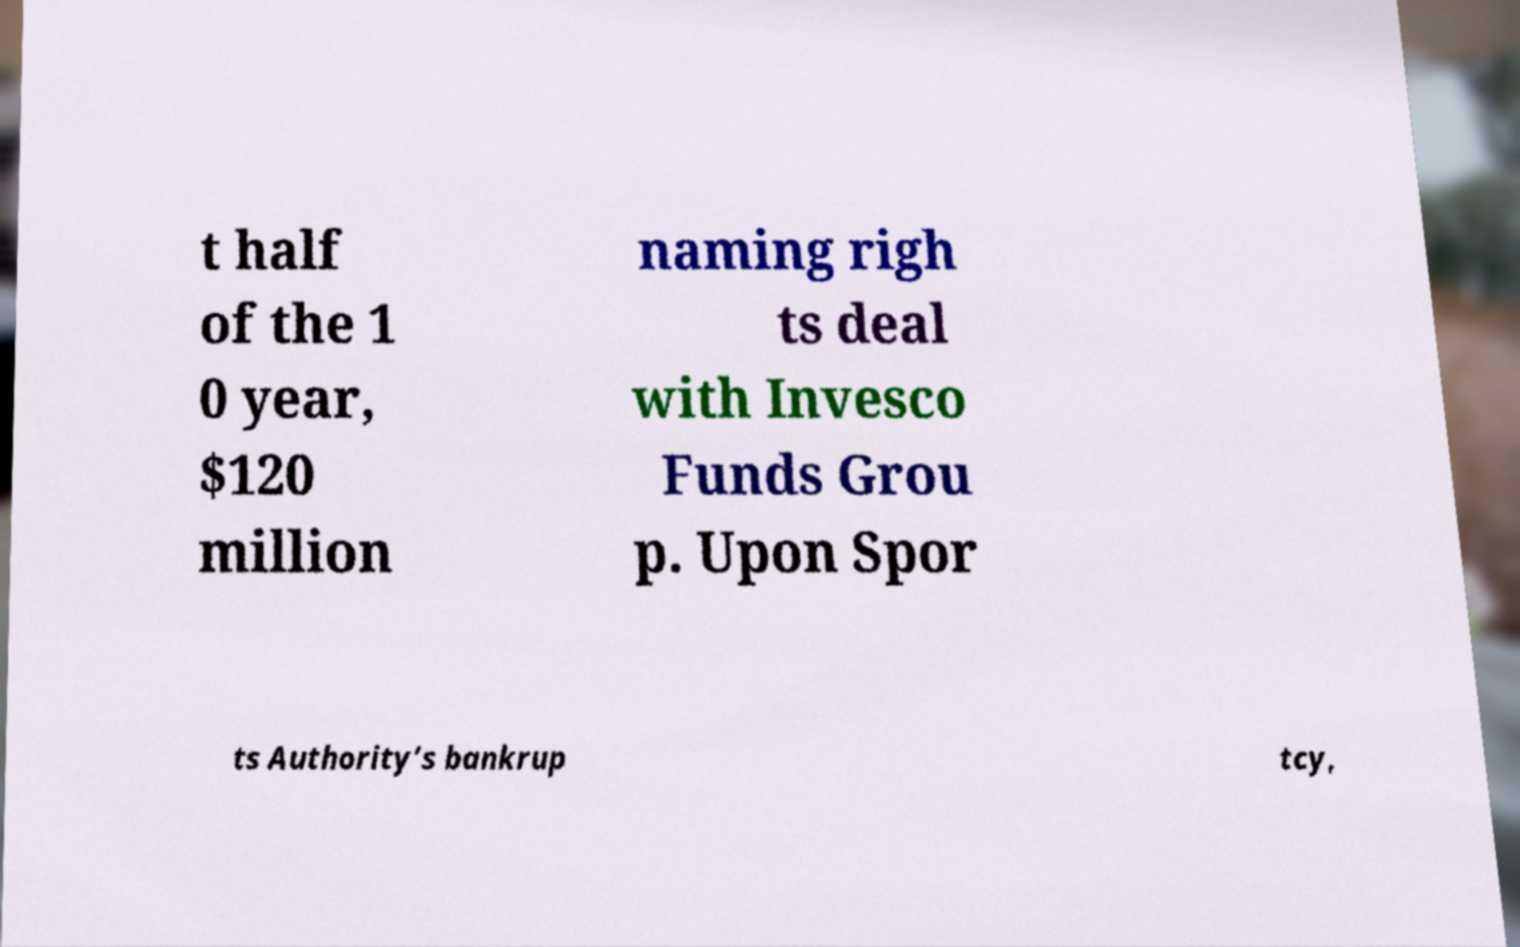I need the written content from this picture converted into text. Can you do that? t half of the 1 0 year, $120 million naming righ ts deal with Invesco Funds Grou p. Upon Spor ts Authority’s bankrup tcy, 